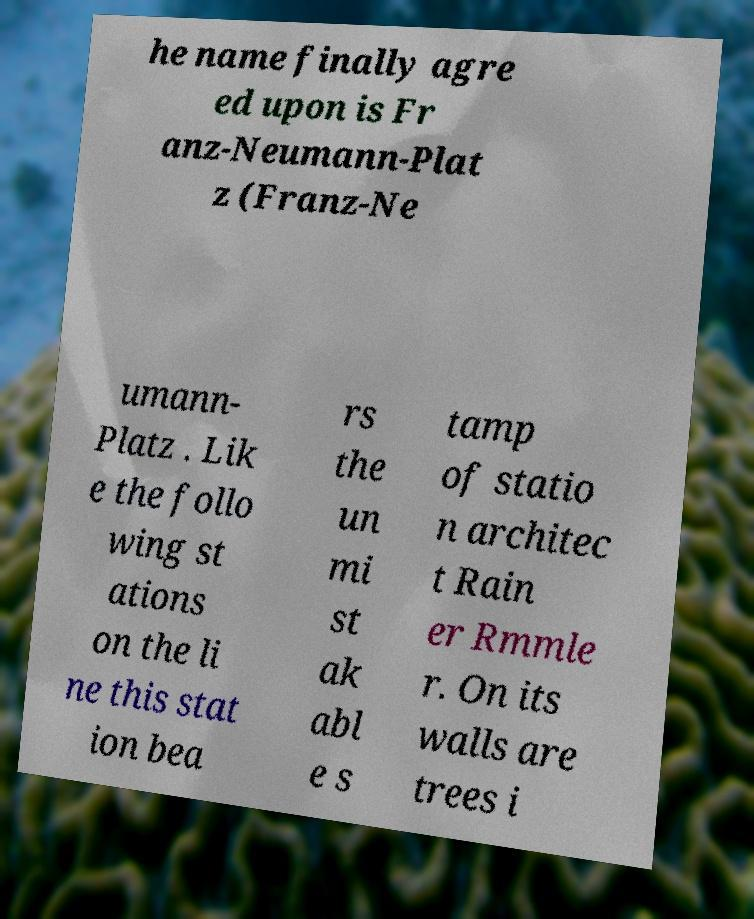Could you extract and type out the text from this image? he name finally agre ed upon is Fr anz-Neumann-Plat z (Franz-Ne umann- Platz . Lik e the follo wing st ations on the li ne this stat ion bea rs the un mi st ak abl e s tamp of statio n architec t Rain er Rmmle r. On its walls are trees i 